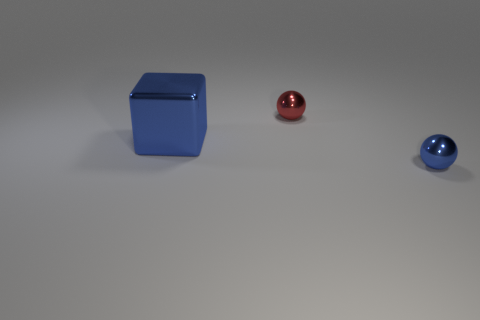What size is the metallic object that is the same color as the big metal cube?
Give a very brief answer. Small. There is a small red object on the left side of the tiny ball in front of the metal ball behind the big thing; what shape is it?
Your response must be concise. Sphere. Are there more blue balls that are to the left of the large blue metallic thing than small balls?
Give a very brief answer. No. There is a metal thing that is behind the big cube; does it have the same shape as the large blue thing?
Provide a succinct answer. No. What material is the blue thing left of the red metal thing?
Give a very brief answer. Metal. What number of other tiny things are the same shape as the small red shiny object?
Your response must be concise. 1. There is a tiny thing that is to the left of the tiny metal ball that is in front of the small red metallic thing; what is it made of?
Offer a terse response. Metal. The small metal object that is the same color as the shiny cube is what shape?
Provide a succinct answer. Sphere. Are there any other big blocks made of the same material as the big blue block?
Your answer should be very brief. No. The red thing is what shape?
Your answer should be compact. Sphere. 